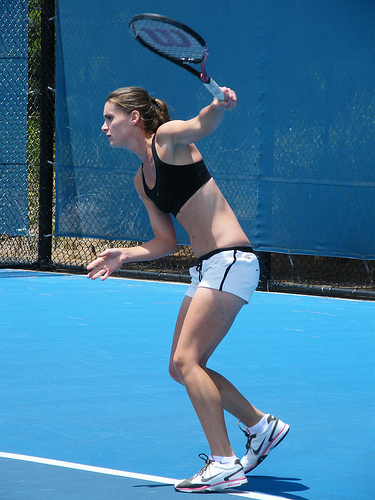Do you see surfboards or bird cages? There are neither surfboards nor bird cages present in the image, which focuses solely on a tennis match. 